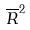Convert formula to latex. <formula><loc_0><loc_0><loc_500><loc_500>\overline { R } ^ { 2 }</formula> 